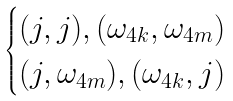<formula> <loc_0><loc_0><loc_500><loc_500>\begin{cases} ( j , j ) , ( \omega _ { 4 k } , \omega _ { 4 m } ) \\ ( j , \omega _ { 4 m } ) , ( \omega _ { 4 k } , j ) \end{cases}</formula> 